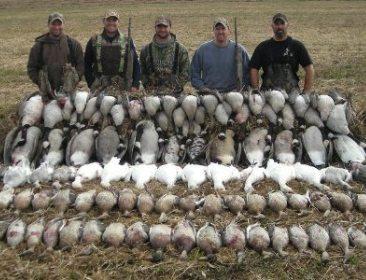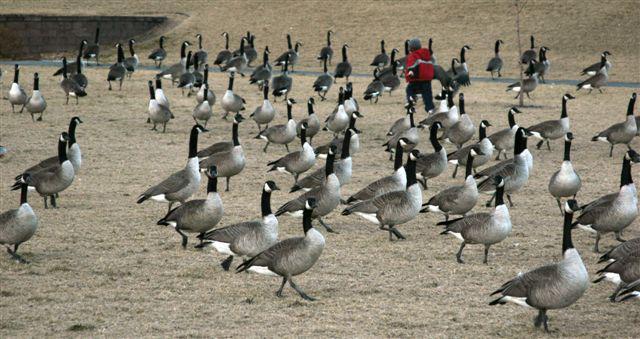The first image is the image on the left, the second image is the image on the right. Considering the images on both sides, is "There are exactly four people in the image on the left." valid? Answer yes or no. No. 